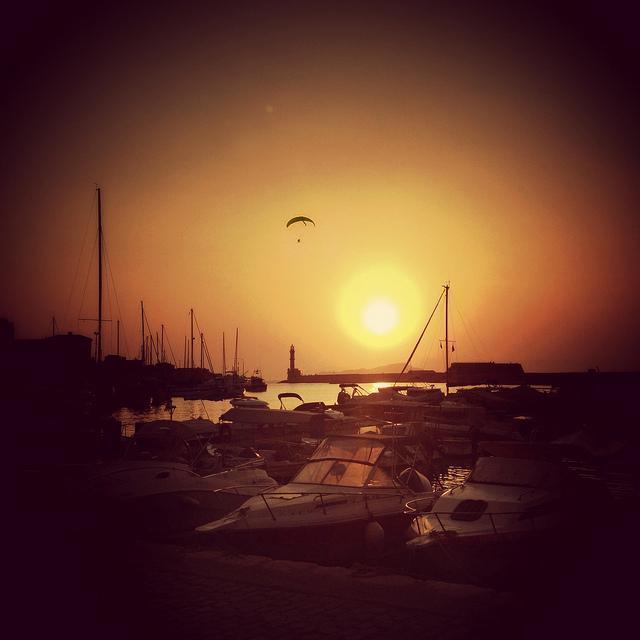This scene is likely to appear where?
Pick the right solution, then justify: 'Answer: answer
Rationale: rationale.'
Options: Babysitter resume, photographers portfolio, dog advertisement, wanted ad. Answer: photographers portfolio.
Rationale: A nice picture of the sky. 